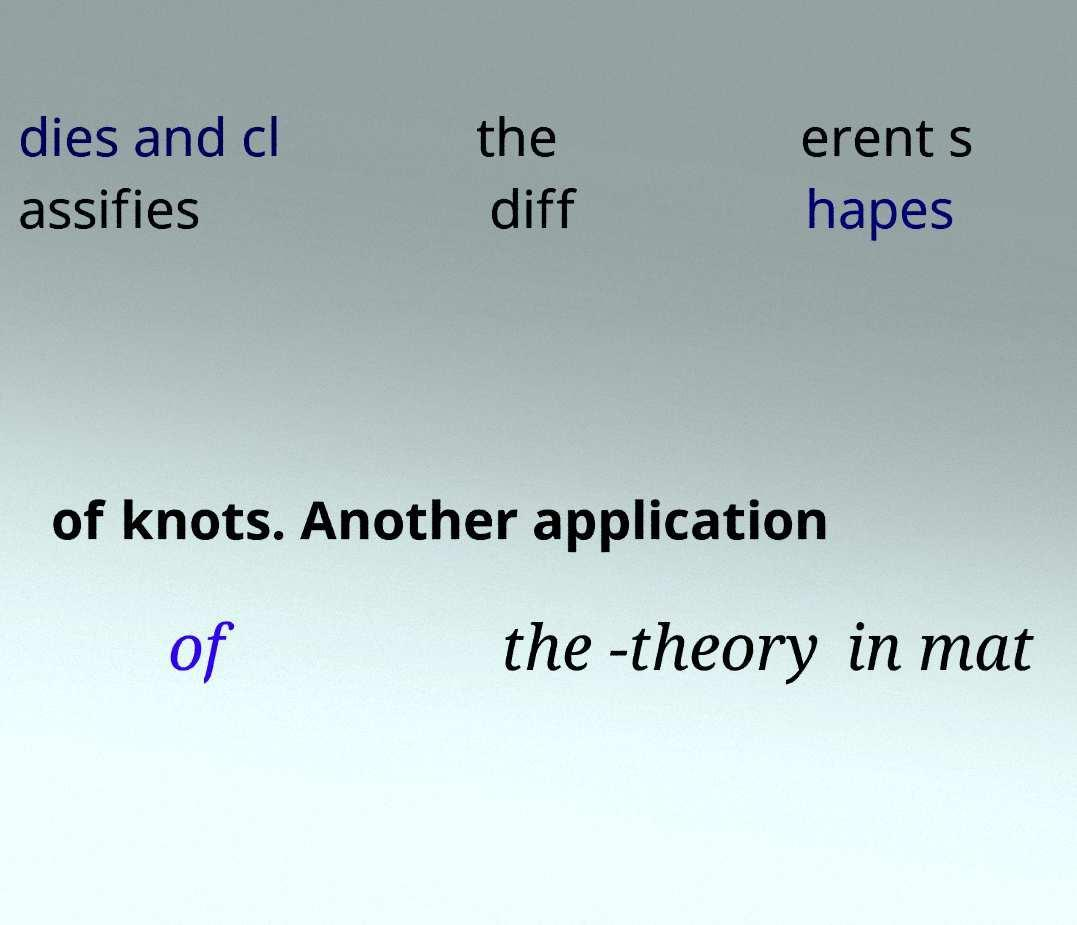Can you read and provide the text displayed in the image?This photo seems to have some interesting text. Can you extract and type it out for me? dies and cl assifies the diff erent s hapes of knots. Another application of the -theory in mat 